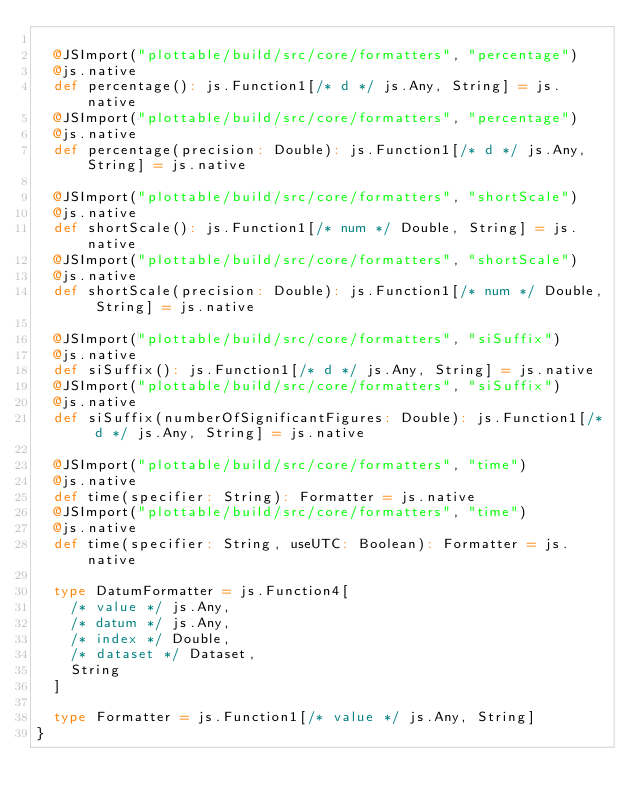Convert code to text. <code><loc_0><loc_0><loc_500><loc_500><_Scala_>  
  @JSImport("plottable/build/src/core/formatters", "percentage")
  @js.native
  def percentage(): js.Function1[/* d */ js.Any, String] = js.native
  @JSImport("plottable/build/src/core/formatters", "percentage")
  @js.native
  def percentage(precision: Double): js.Function1[/* d */ js.Any, String] = js.native
  
  @JSImport("plottable/build/src/core/formatters", "shortScale")
  @js.native
  def shortScale(): js.Function1[/* num */ Double, String] = js.native
  @JSImport("plottable/build/src/core/formatters", "shortScale")
  @js.native
  def shortScale(precision: Double): js.Function1[/* num */ Double, String] = js.native
  
  @JSImport("plottable/build/src/core/formatters", "siSuffix")
  @js.native
  def siSuffix(): js.Function1[/* d */ js.Any, String] = js.native
  @JSImport("plottable/build/src/core/formatters", "siSuffix")
  @js.native
  def siSuffix(numberOfSignificantFigures: Double): js.Function1[/* d */ js.Any, String] = js.native
  
  @JSImport("plottable/build/src/core/formatters", "time")
  @js.native
  def time(specifier: String): Formatter = js.native
  @JSImport("plottable/build/src/core/formatters", "time")
  @js.native
  def time(specifier: String, useUTC: Boolean): Formatter = js.native
  
  type DatumFormatter = js.Function4[
    /* value */ js.Any, 
    /* datum */ js.Any, 
    /* index */ Double, 
    /* dataset */ Dataset, 
    String
  ]
  
  type Formatter = js.Function1[/* value */ js.Any, String]
}
</code> 